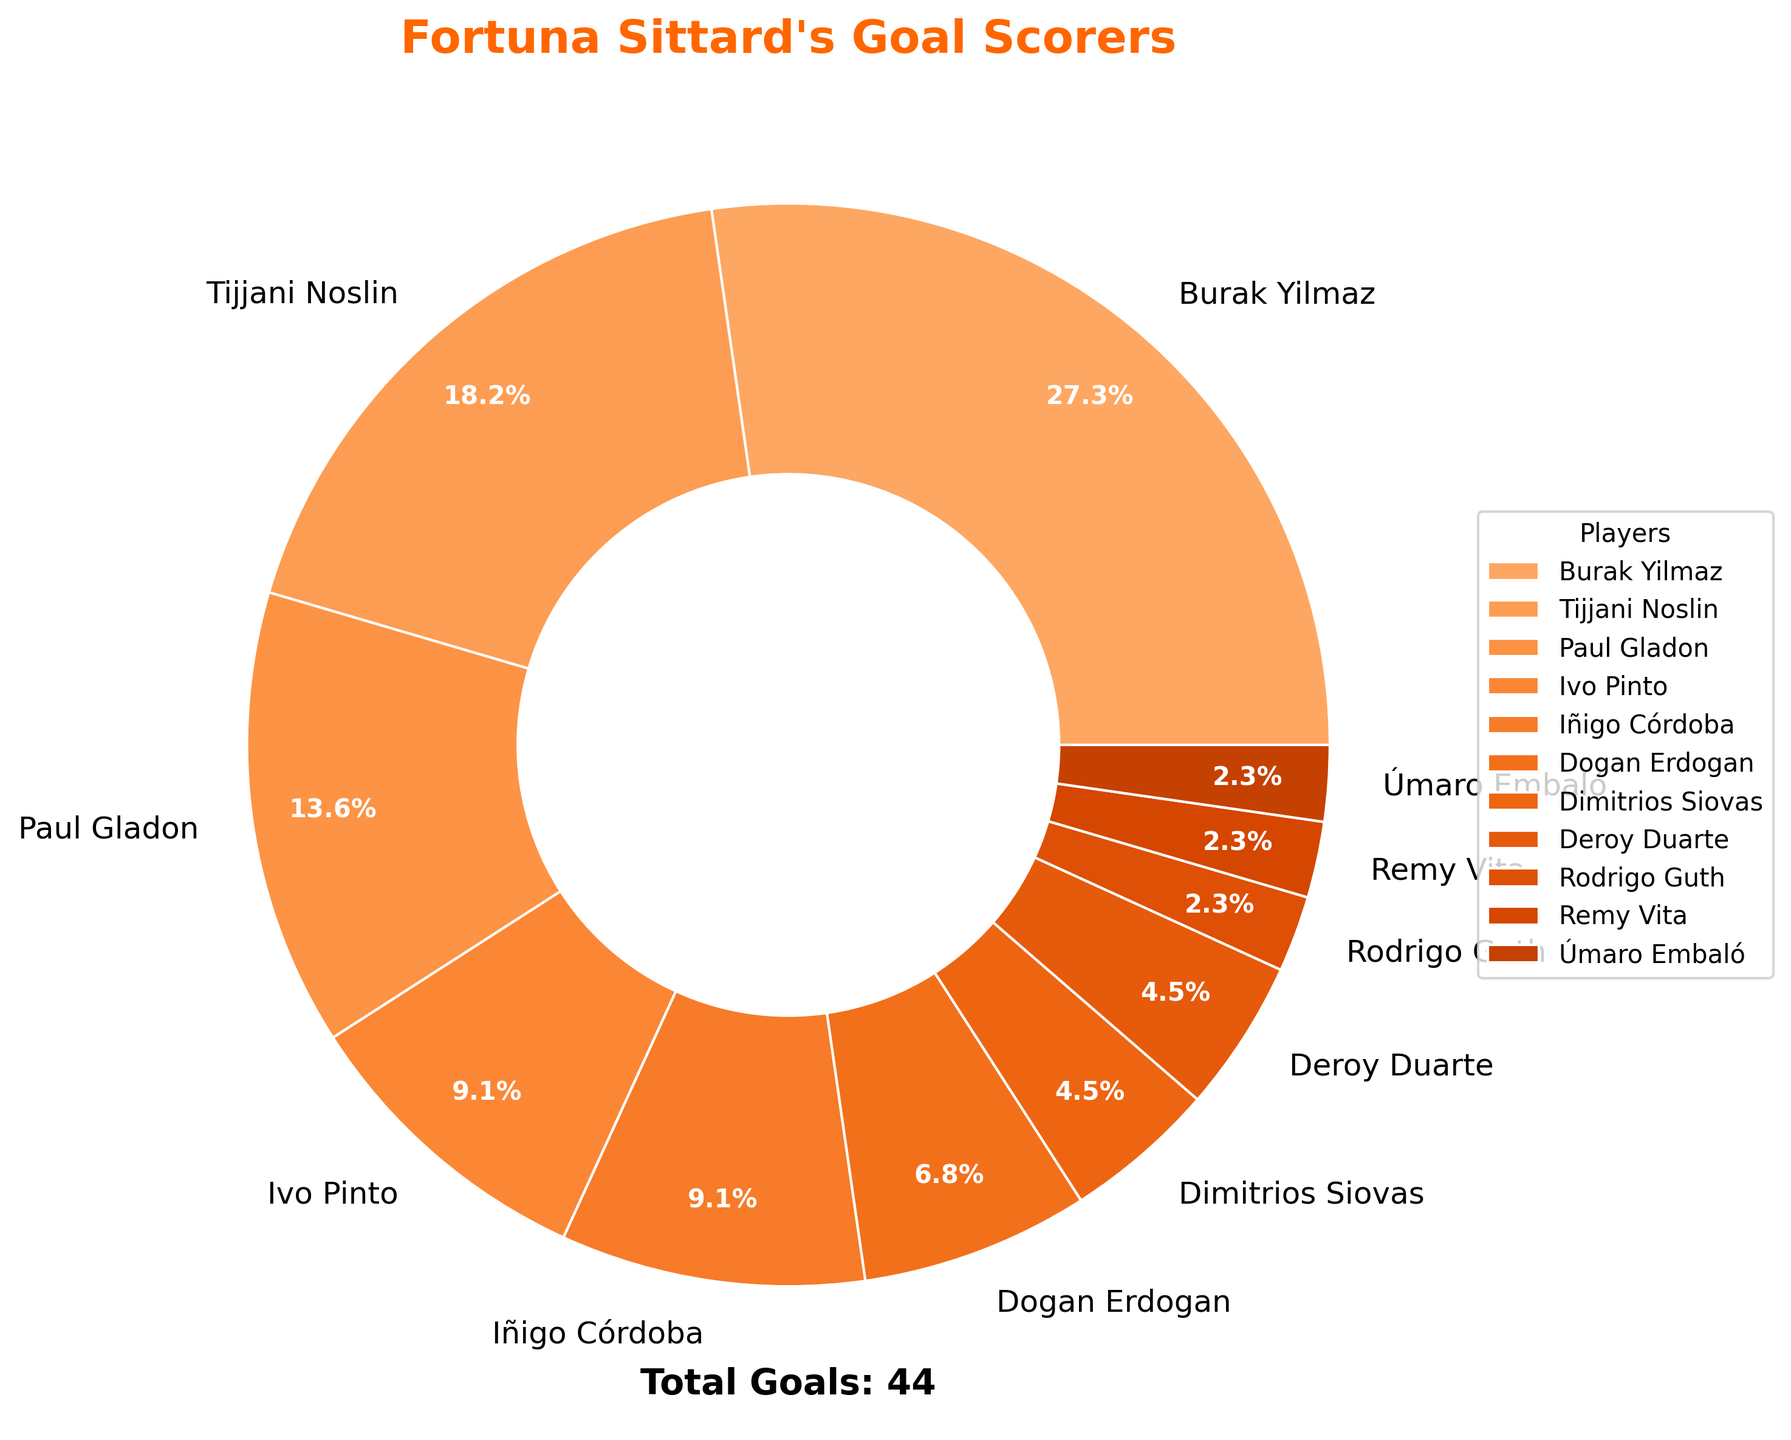What's the percentage of goals scored by Burak Yilmaz? Burak Yilmaz has scored 12 goals out of the total goals scored by all players. The total number of goals is 44. The percentage is calculated by (12/44) * 100, which equals approximately 27.3%.
Answer: 27.3% What’s the difference in the number of goals scored by Burak Yilmaz and Tijjani Noslin? Burak Yilmaz scored 12 goals and Tijjani Noslin scored 8 goals. The difference is 12 - 8, which equals 4.
Answer: 4 Out of the total goals scored, what is the combined percentage contribution of Paul Gladon and Ivo Pinto? Paul Gladon scored 6 goals and Ivo Pinto scored 4 goals. So, their combined goals are 6 + 4 = 10. The percentage contribution is (10/44) * 100 = 22.7%.
Answer: 22.7% Which player scored the least number of goals? Each of Úmaro Embaló, Remy Vita, and Rodrigo Guth scored 1 goal, and they are the players with the least number of goals.
Answer: Úmaro Embaló, Remy Vita, Rodrigo Guth Is the number of goals by Dimitrios Siovas greater than the number of goals by Deroy Duarte? Dimitrios Siovas scored 2 goals and Deroy Duarte also scored 2 goals. Since they both scored the same number of goals, one is not greater than the other.
Answer: No How many players scored more than 4 goals? The players who scored more than 4 goals are Burak Yilmaz (12 goals) and Tijjani Noslin (8 goals), making a total of 2 players.
Answer: 2 What is the sum of goals by the top 3 goal scorers? The top 3 goal scorers are Burak Yilmaz (12), Tijjani Noslin (8), and Paul Gladon (6). Their combined goals are 12 + 8 + 6 = 26.
Answer: 26 What percentage of goals were scored by players other than Burak Yilmaz and Tijjani Noslin? Burak Yilmaz and Tijjani Noslin scored a combined 20 goals (12 + 8). The total goals are 44, so goals scored by others are 44 - 20 = 24. The percentage is (24/44) * 100, which equals approximately 54.5%.
Answer: 54.5% How many players scored at least 2 goals this season? The players who scored at least 2 goals are Burak Yilmaz (12), Tijjani Noslin (8), Paul Gladon (6), Ivo Pinto (4), Iñigo Córdoba (4), Dogan Erdogan (3), Dimitrios Siovas (2), and Deroy Duarte (2), making a total of 8 players.
Answer: 8 